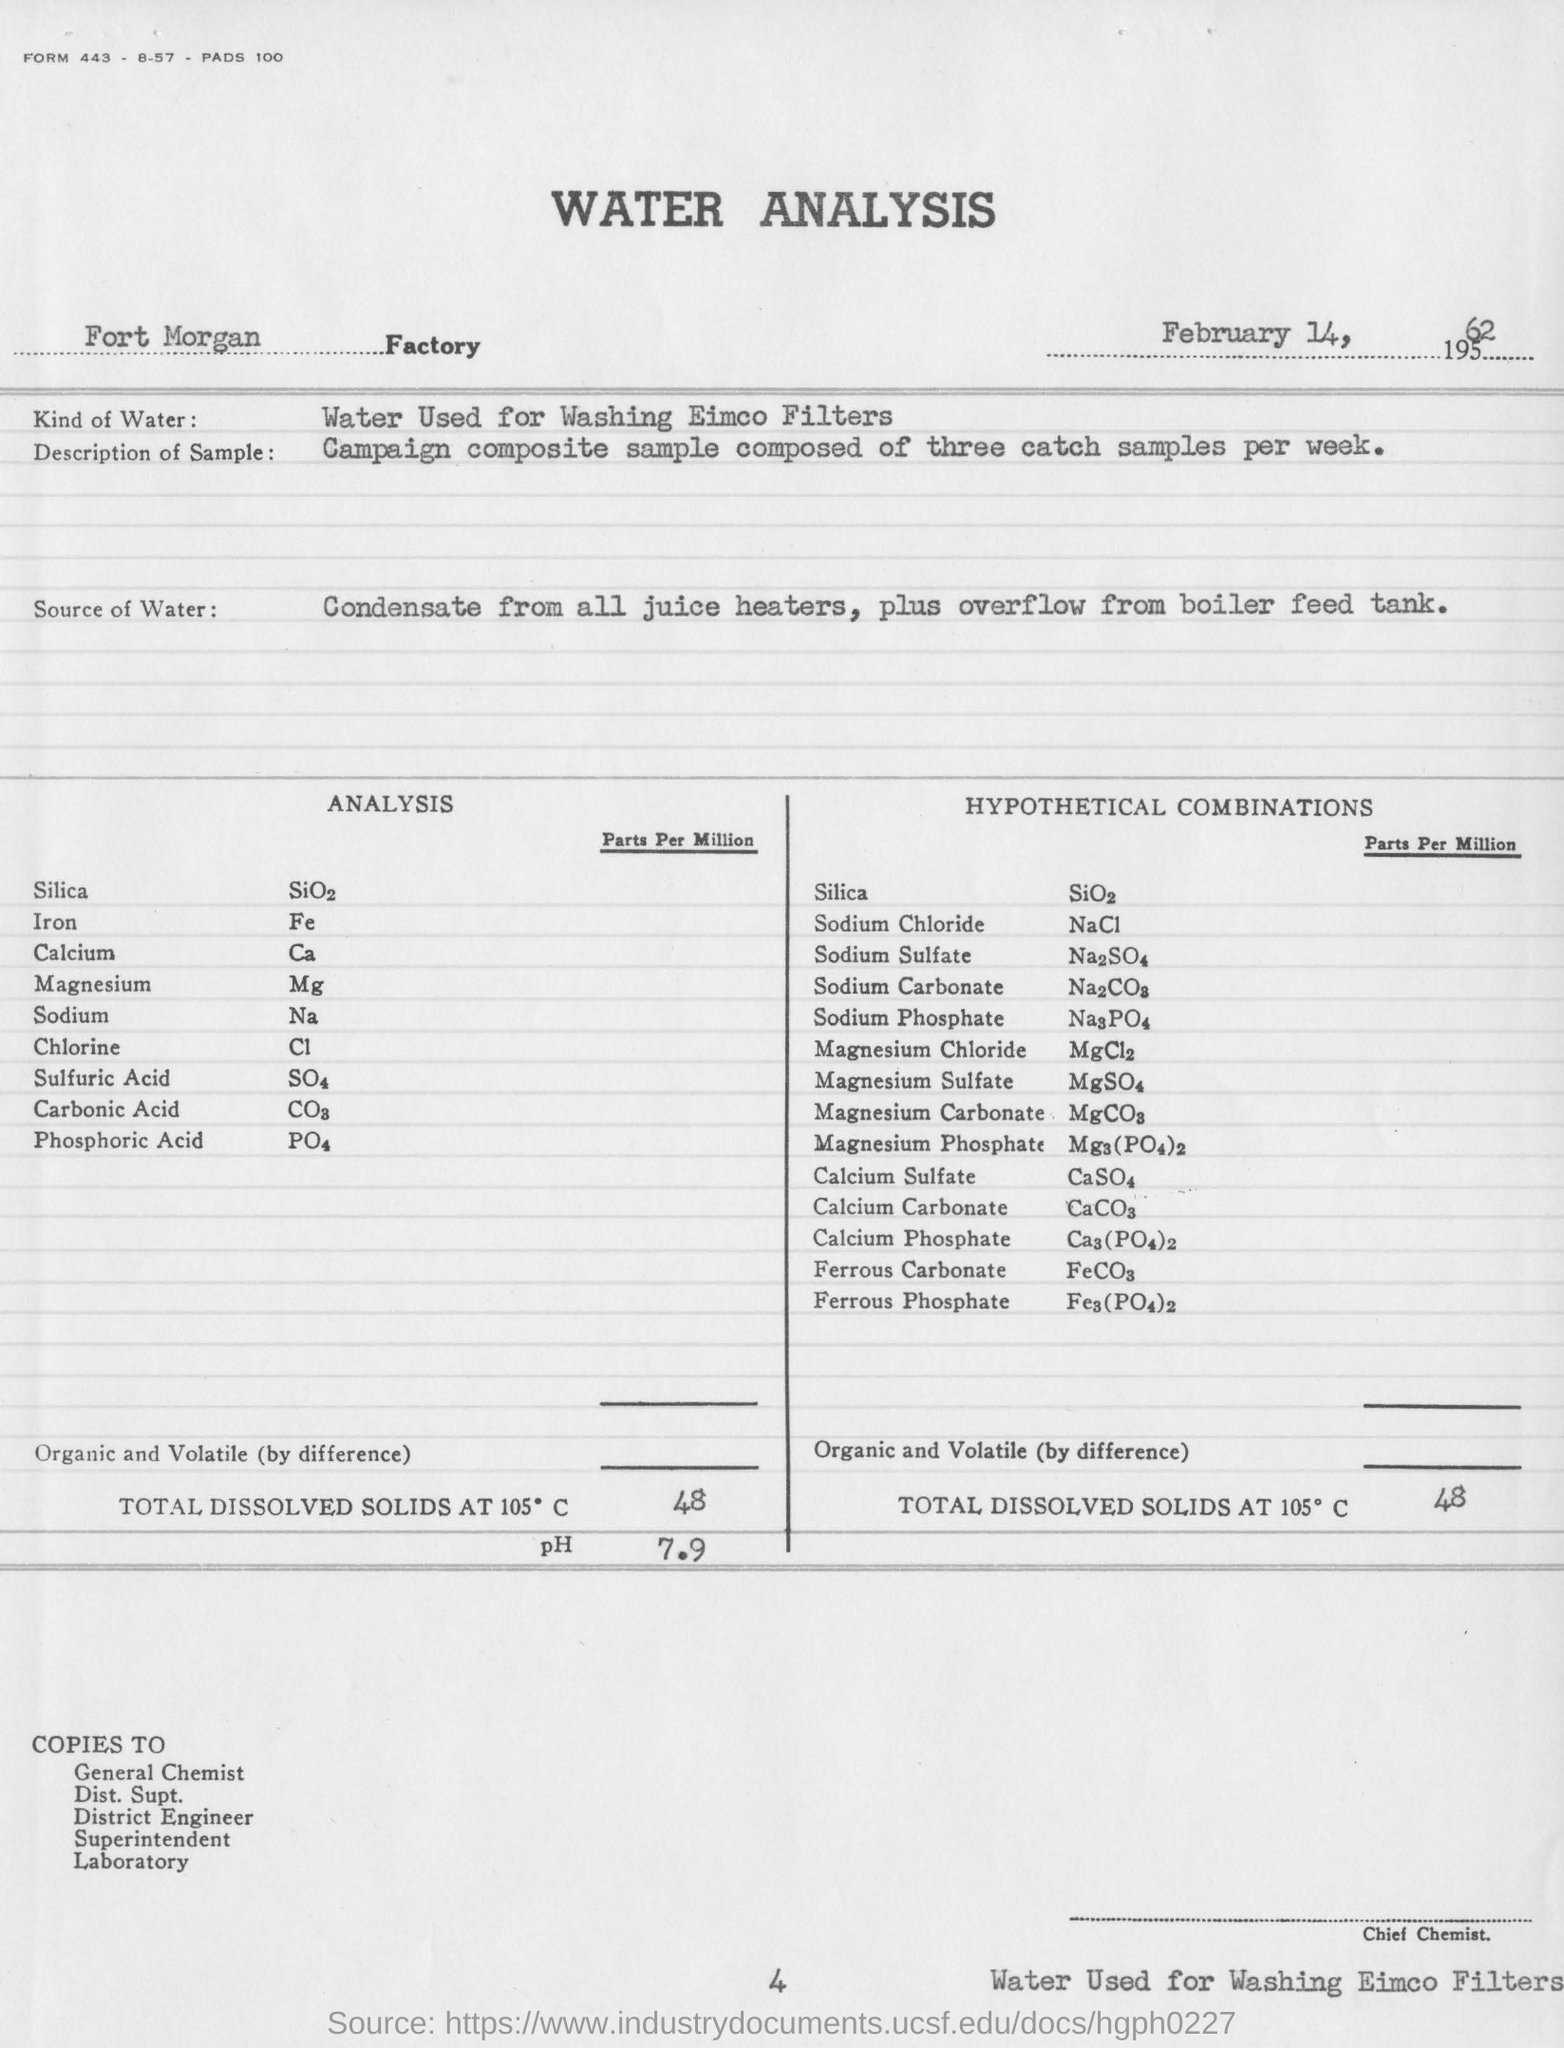Give some essential details in this illustration. The third compound under the title of 'Analysis' is C. The pH value of the sample in the analysis is 7.9. The total dissolved solids at 105°C in the hypothetical combination is 48%. The formula for iron is Fe, which represents the chemical element iron and its atomic number. The Fort Morgan Factory Test was conducted on February 14, 1962. 